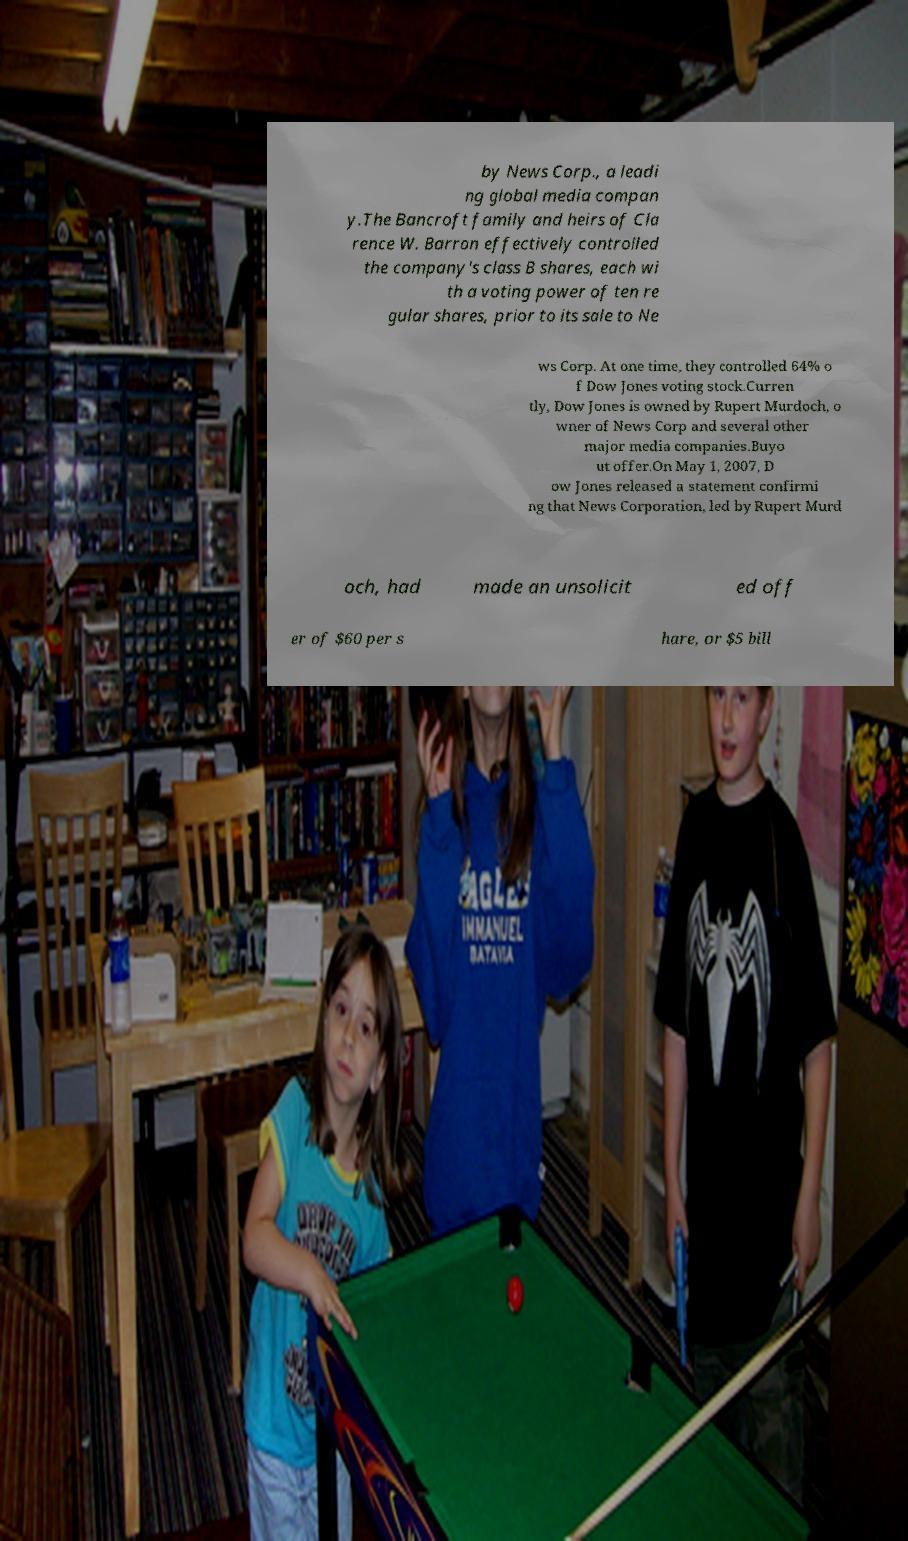For documentation purposes, I need the text within this image transcribed. Could you provide that? by News Corp., a leadi ng global media compan y.The Bancroft family and heirs of Cla rence W. Barron effectively controlled the company's class B shares, each wi th a voting power of ten re gular shares, prior to its sale to Ne ws Corp. At one time, they controlled 64% o f Dow Jones voting stock.Curren tly, Dow Jones is owned by Rupert Murdoch, o wner of News Corp and several other major media companies.Buyo ut offer.On May 1, 2007, D ow Jones released a statement confirmi ng that News Corporation, led by Rupert Murd och, had made an unsolicit ed off er of $60 per s hare, or $5 bill 